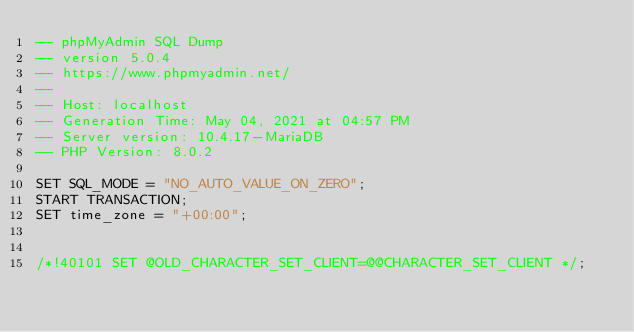<code> <loc_0><loc_0><loc_500><loc_500><_SQL_>-- phpMyAdmin SQL Dump
-- version 5.0.4
-- https://www.phpmyadmin.net/
--
-- Host: localhost
-- Generation Time: May 04, 2021 at 04:57 PM
-- Server version: 10.4.17-MariaDB
-- PHP Version: 8.0.2

SET SQL_MODE = "NO_AUTO_VALUE_ON_ZERO";
START TRANSACTION;
SET time_zone = "+00:00";


/*!40101 SET @OLD_CHARACTER_SET_CLIENT=@@CHARACTER_SET_CLIENT */;</code> 